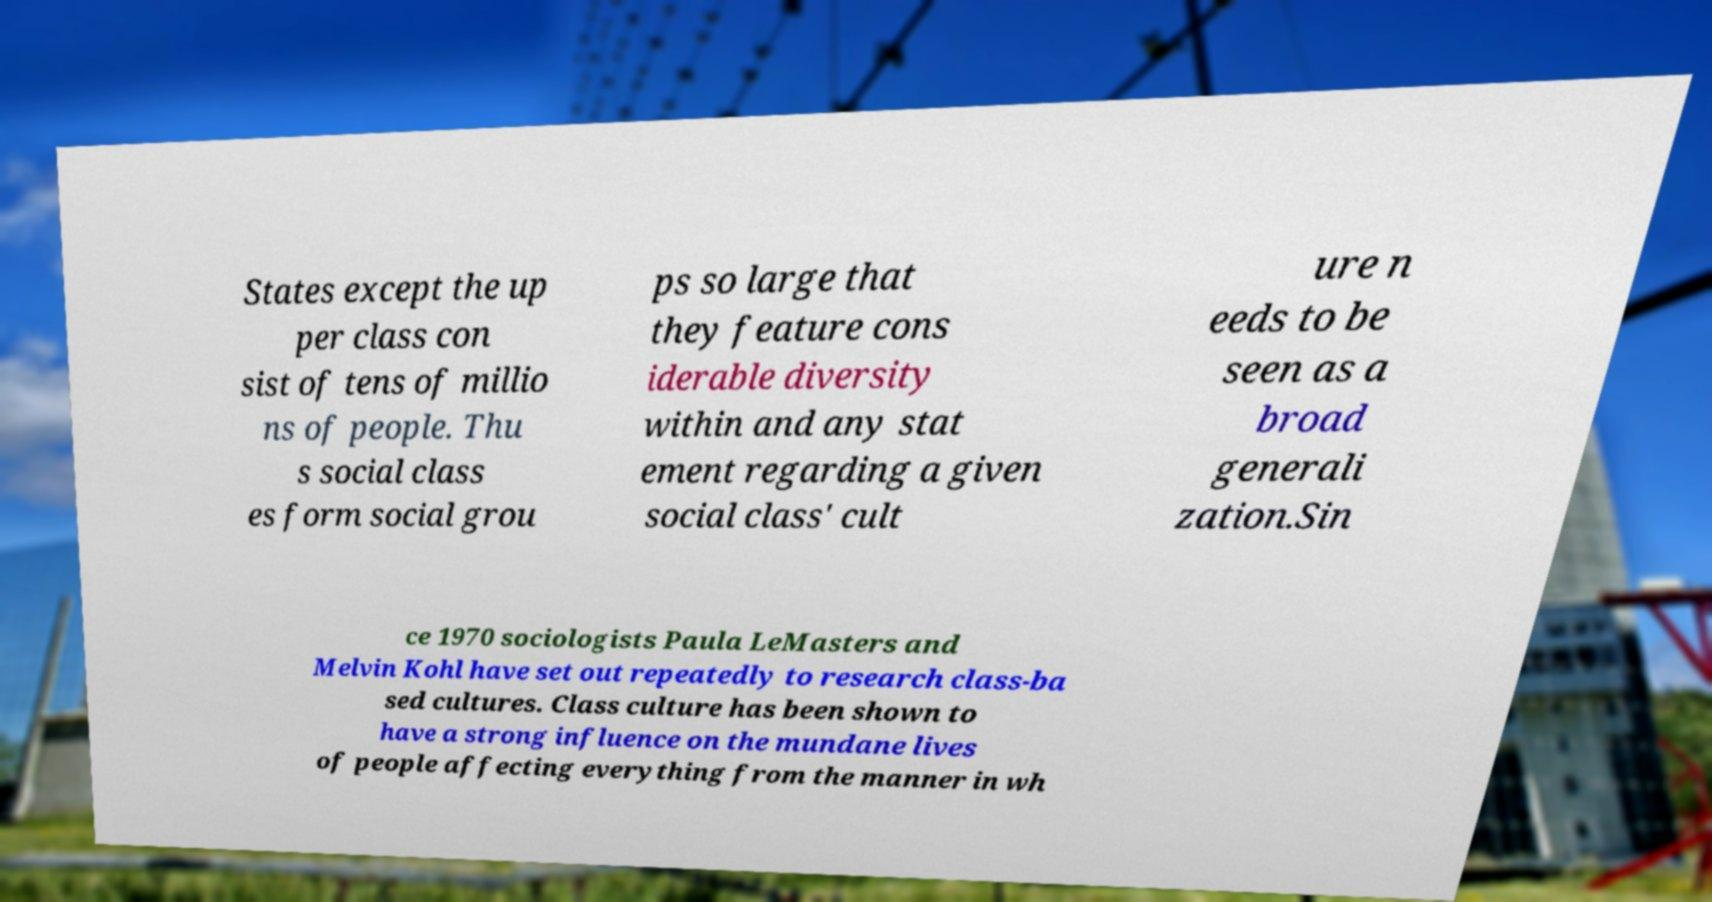I need the written content from this picture converted into text. Can you do that? States except the up per class con sist of tens of millio ns of people. Thu s social class es form social grou ps so large that they feature cons iderable diversity within and any stat ement regarding a given social class' cult ure n eeds to be seen as a broad generali zation.Sin ce 1970 sociologists Paula LeMasters and Melvin Kohl have set out repeatedly to research class-ba sed cultures. Class culture has been shown to have a strong influence on the mundane lives of people affecting everything from the manner in wh 